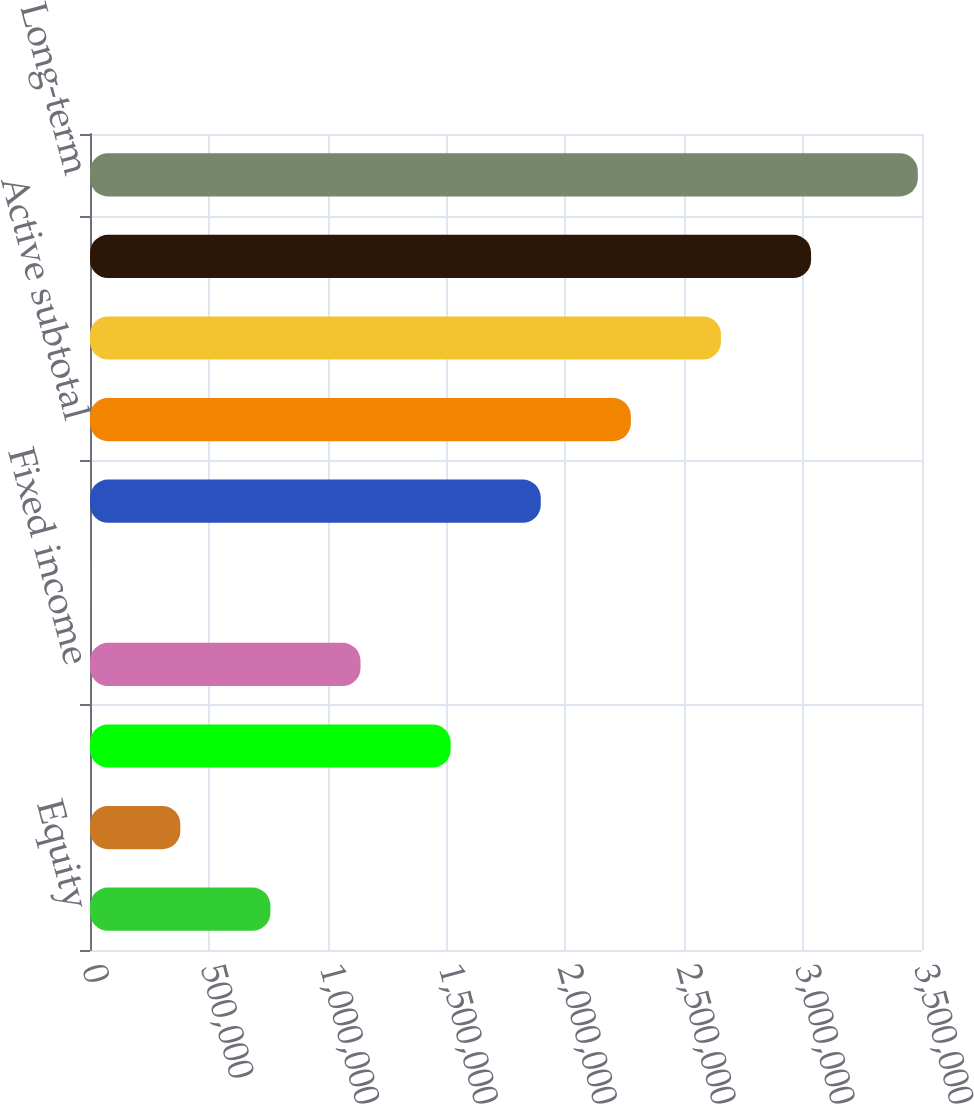<chart> <loc_0><loc_0><loc_500><loc_500><bar_chart><fcel>Equity<fcel>Alternatives<fcel>Retail subtotal<fcel>Fixed income<fcel>Multi-asset<fcel>iShares subtotal<fcel>Active subtotal<fcel>Index subtotal<fcel>Institutional subtotal<fcel>Long-term<nl><fcel>759013<fcel>379941<fcel>1.51716e+06<fcel>1.13808e+06<fcel>869<fcel>1.89623e+06<fcel>2.2753e+06<fcel>2.65437e+06<fcel>3.03344e+06<fcel>3.48237e+06<nl></chart> 